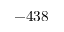Convert formula to latex. <formula><loc_0><loc_0><loc_500><loc_500>- 4 3 8</formula> 